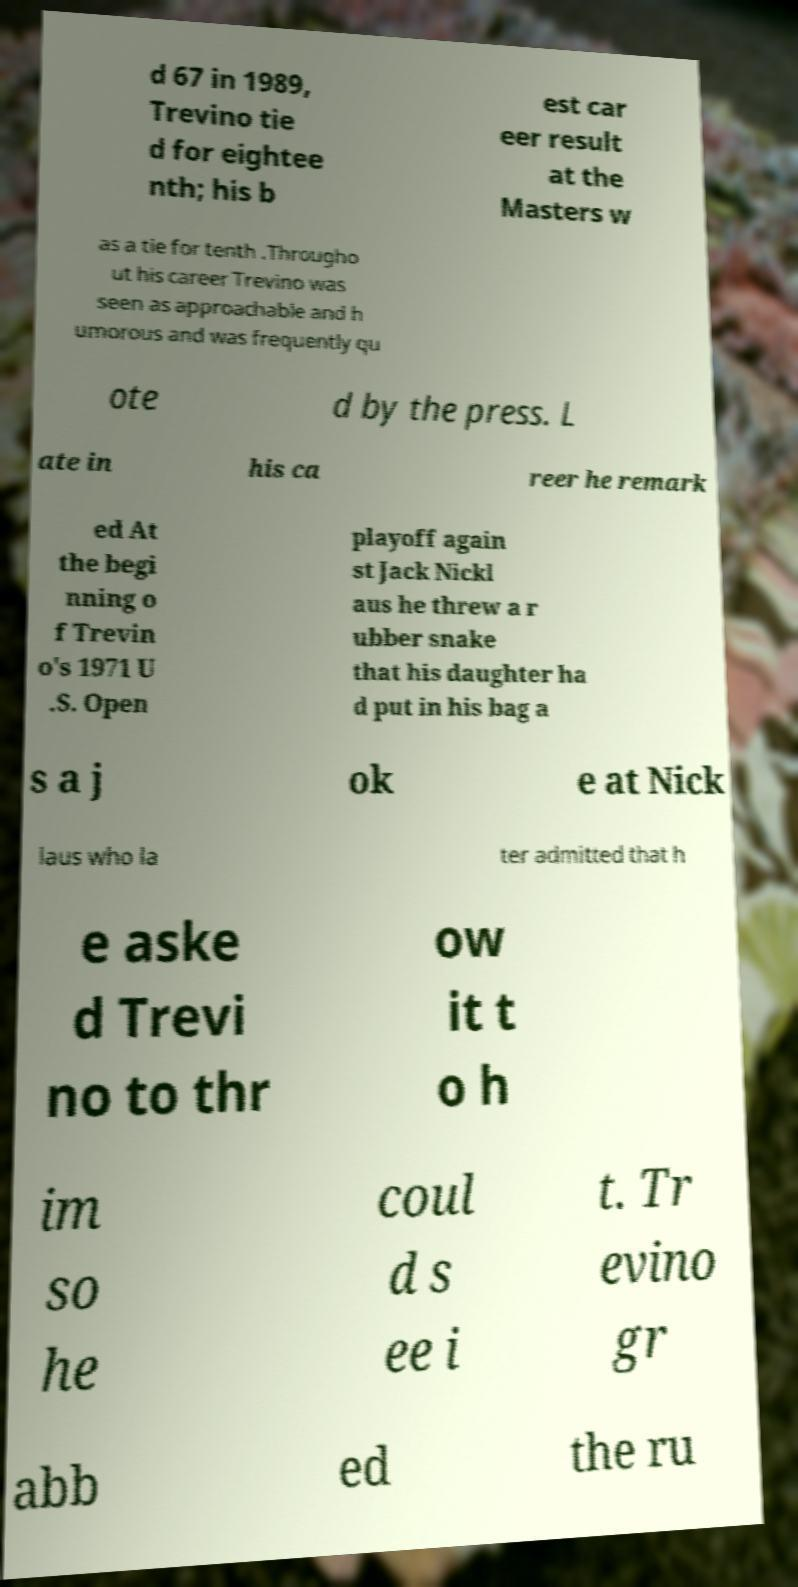Please read and relay the text visible in this image. What does it say? d 67 in 1989, Trevino tie d for eightee nth; his b est car eer result at the Masters w as a tie for tenth .Througho ut his career Trevino was seen as approachable and h umorous and was frequently qu ote d by the press. L ate in his ca reer he remark ed At the begi nning o f Trevin o's 1971 U .S. Open playoff again st Jack Nickl aus he threw a r ubber snake that his daughter ha d put in his bag a s a j ok e at Nick laus who la ter admitted that h e aske d Trevi no to thr ow it t o h im so he coul d s ee i t. Tr evino gr abb ed the ru 